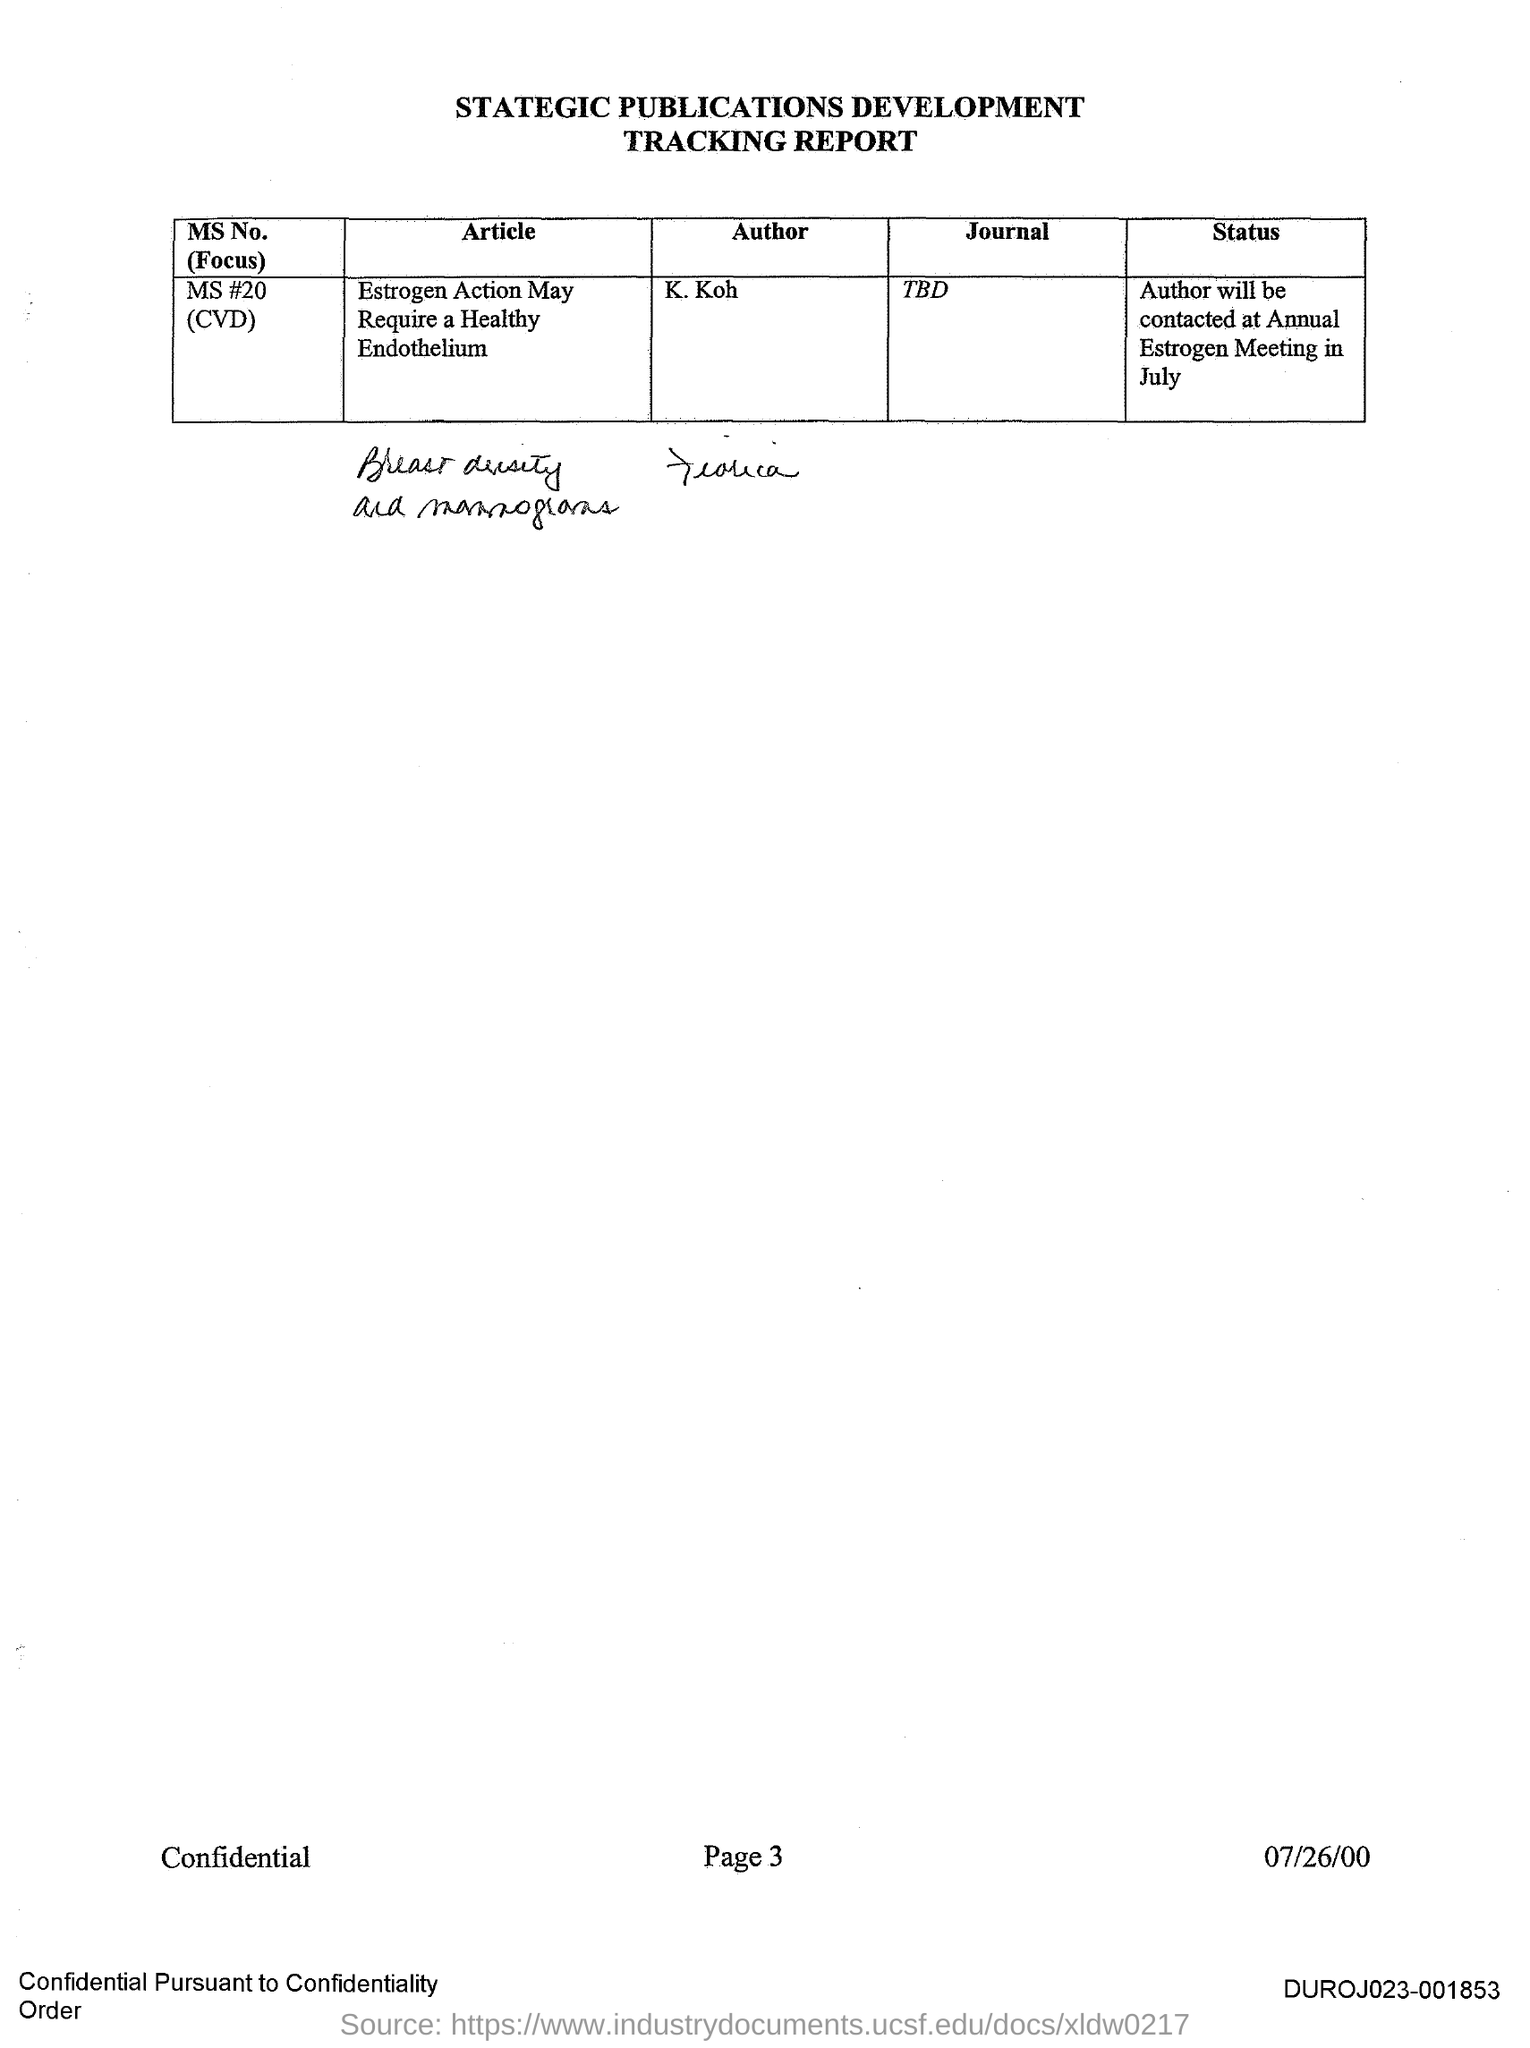Draw attention to some important aspects in this diagram. The author of MS No. #20 (CVD) is K. Koh. 